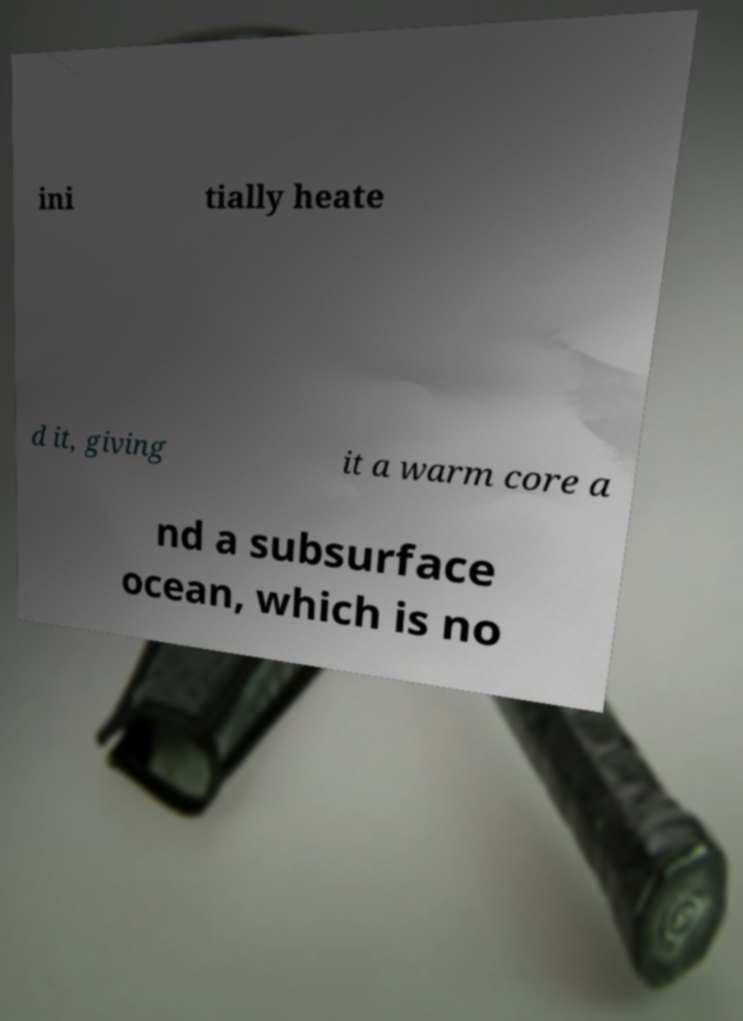Can you accurately transcribe the text from the provided image for me? ini tially heate d it, giving it a warm core a nd a subsurface ocean, which is no 